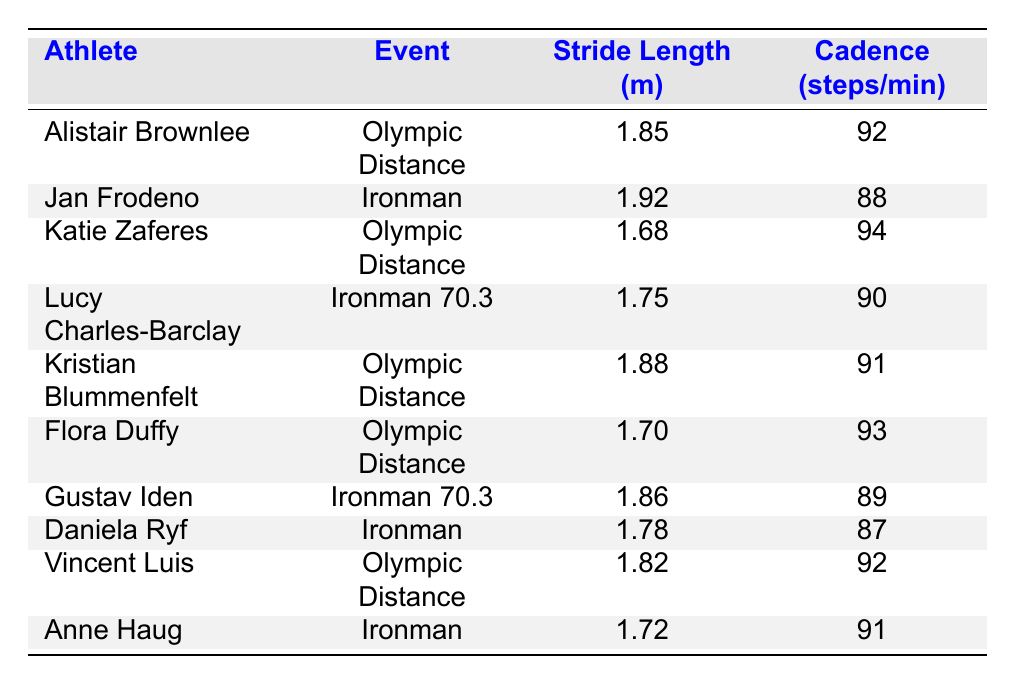What is the stride length of Jan Frodeno? Referring to the table, Jan Frodeno has a listed stride length of 1.92 meters under the Ironman event.
Answer: 1.92 m Which athlete has the highest cadence? Looking through the 'Cadence (steps/min)' column, Katie Zaferes has the highest cadence at 94 steps/min.
Answer: 94 steps/min What is the average stride length of the athletes in the Olympic Distance event? The stride lengths for the athletes in the Olympic Distance are: Alistair Brownlee (1.85), Katie Zaferes (1.68), Kristian Blummenfelt (1.88), Flora Duffy (1.70), and Vincent Luis (1.82). Summing these gives 1.85 + 1.68 + 1.88 + 1.70 + 1.82 = 9.91, and dividing by the number of athletes (5) gives an average of 9.91/5 = 1.982.
Answer: 1.982 m Is the cadence of Lucy Charles-Barclay greater than that of Daniela Ryf? Checking the 'Cadence (steps/min)' values, Lucy Charles-Barclay has a cadence of 90 steps/min, while Daniela Ryf has 87 steps/min. Since 90 is greater than 87, the answer is true.
Answer: Yes Which event has the lowest average stride length? First, we identify the stride lengths for each event: Olympic Distance (1.85, 1.68, 1.88, 1.70, 1.82) sums to 9.91 and has 5 entries; for Ironman (1.92, 1.78, 1.72), the sum is 5.42 for 3 entries; and for Ironman 70.3 (1.75, 1.86), the sum is 3.61 for 2 entries. The averages therefore are: Olympic Distance (9.91/5 = 1.982), Ironman (5.42/3 = 1.807), Ironman 70.3 (3.61/2 = 1.805). The lowest average is 1.805 from Ironman 70.3.
Answer: Ironman 70.3 Does Gustav Iden have a longer stride length than Alistair Brownlee? From the table, Gustav Iden's stride length is 1.86 m, and Alistair Brownlee's is 1.85 m. Since 1.86 is greater than 1.85, we confirm that Gustav Iden has a longer stride length.
Answer: Yes What is the difference in cadence between Christian Blummenfelt and Anne Haug? Kristian Blummenfelt's cadence is 91 and Anne Haug's is also 91. The difference is 91 - 91, which equals 0.
Answer: 0 steps/min Which athlete has the shortest stride length? By inspecting the 'Stride Length (m)' data, Katie Zaferes has the shortest stride length of 1.68 m.
Answer: 1.68 m 